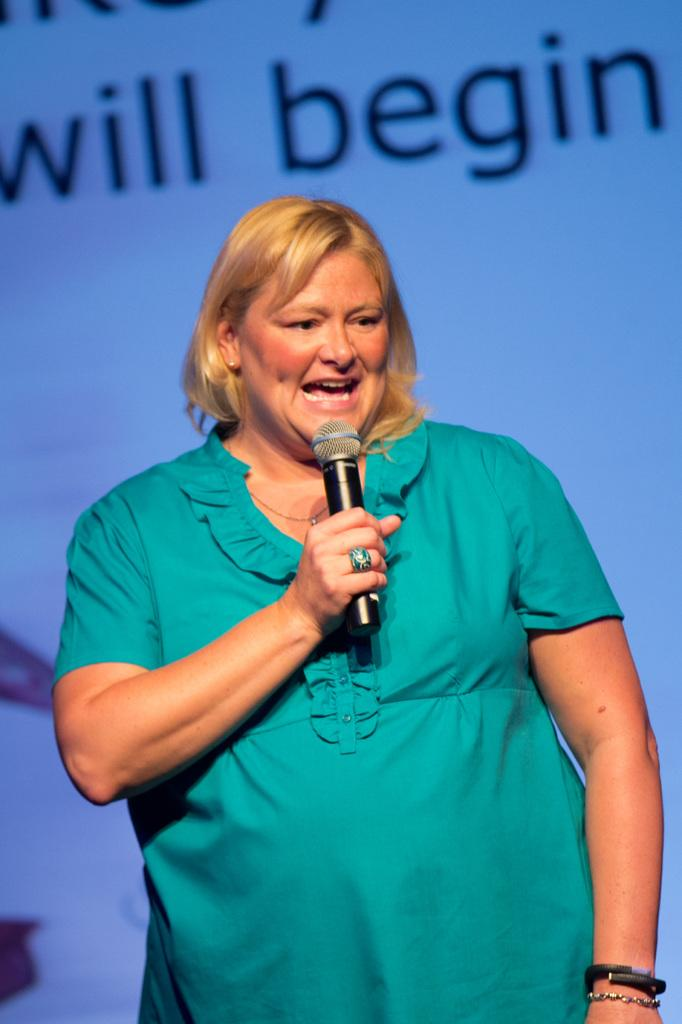Who is the main subject in the image? There is a woman in the image. What is the woman wearing? The woman is wearing a green dress. What is the woman doing in the image? The woman is giving a speech. What can be seen in the background of the image? There is a presentation in the background of the image. How many rabbits can be seen in the image? There are no rabbits present in the image. What type of plough is being used in the image? There is no plough present in the image. 